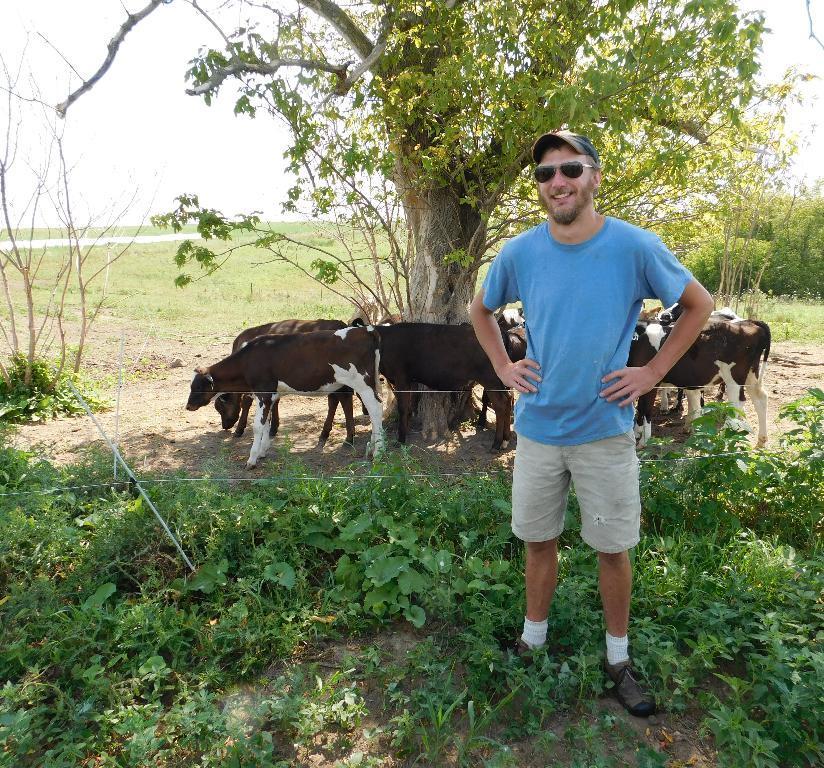In one or two sentences, can you explain what this image depicts? In this picture we can see a man wore a cap, goggles, standing on the ground and smiling. At the back of him we can see plants, fence, animals, grass, trees and the sky. 